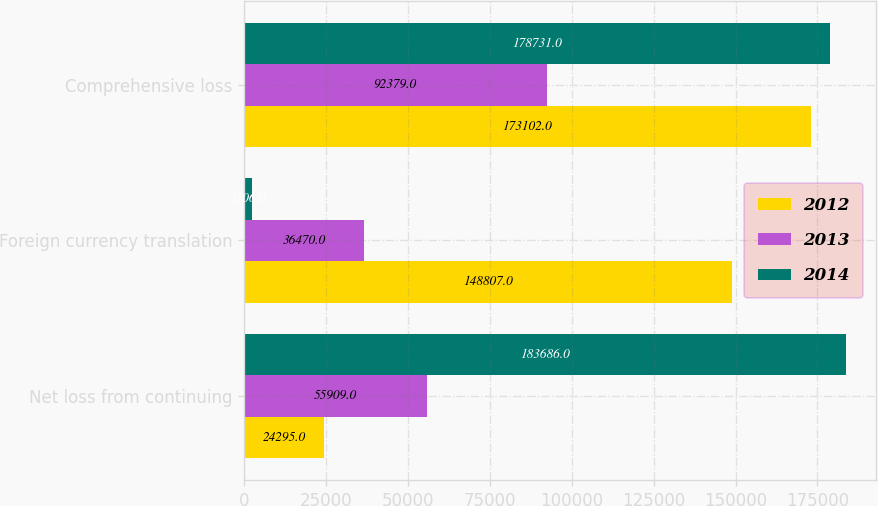<chart> <loc_0><loc_0><loc_500><loc_500><stacked_bar_chart><ecel><fcel>Net loss from continuing<fcel>Foreign currency translation<fcel>Comprehensive loss<nl><fcel>2012<fcel>24295<fcel>148807<fcel>173102<nl><fcel>2013<fcel>55909<fcel>36470<fcel>92379<nl><fcel>2014<fcel>183686<fcel>2306<fcel>178731<nl></chart> 